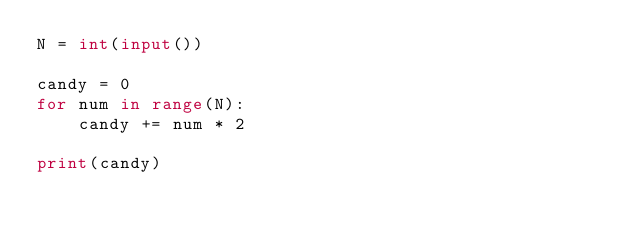<code> <loc_0><loc_0><loc_500><loc_500><_Python_>N = int(input())

candy = 0
for num in range(N):
    candy += num * 2

print(candy)</code> 